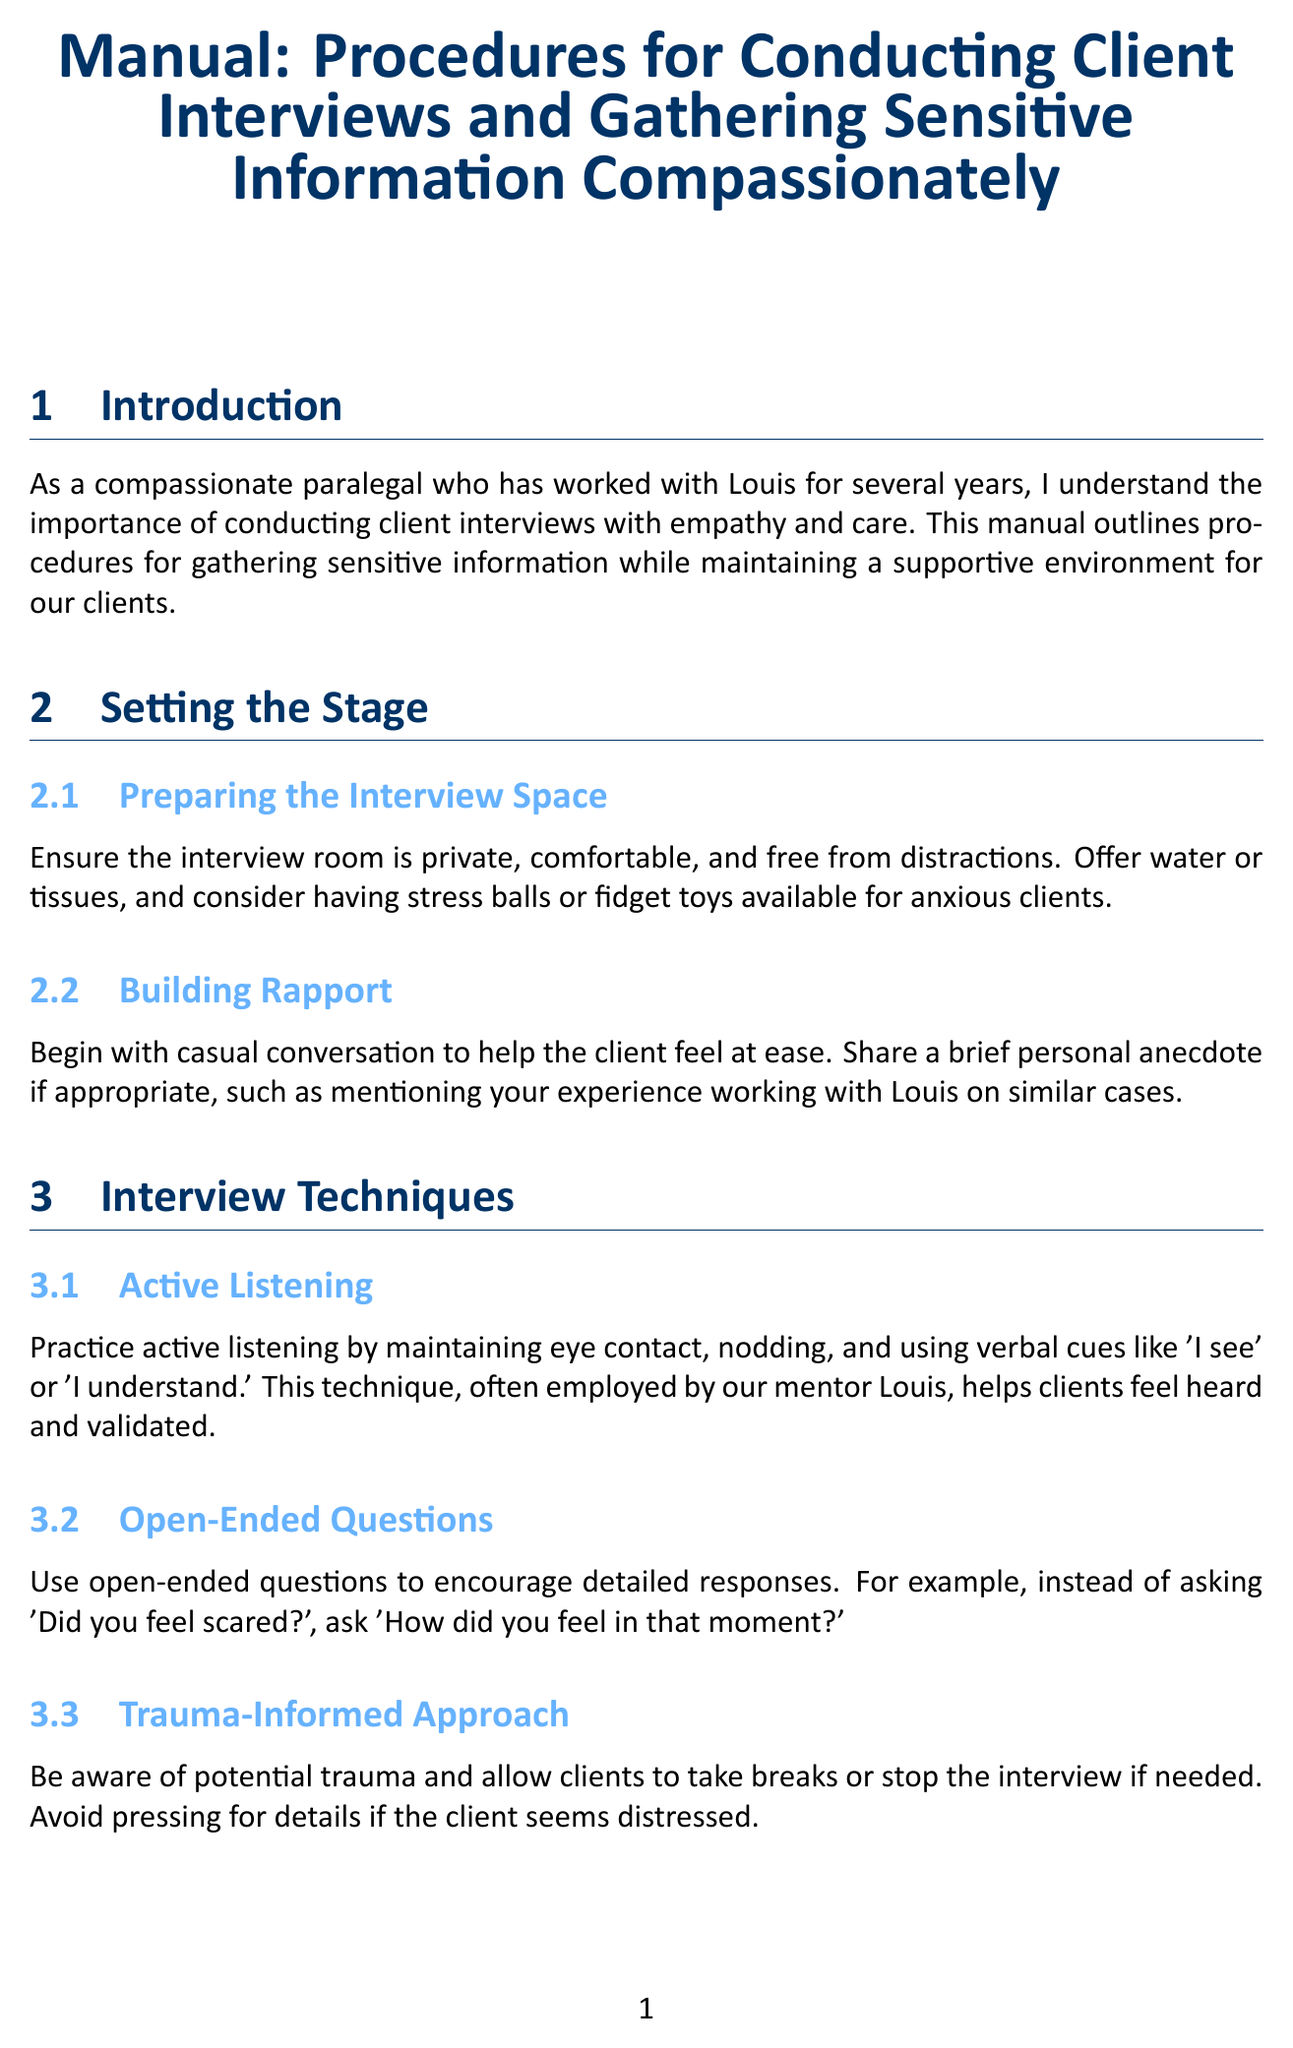What is the title of the manual? The title is stated in the introduction section of the document.
Answer: Manual: Procedures for Conducting Client Interviews and Gathering Sensitive Information Compassionately What is one technique mentioned for building rapport? The section on building rapport provides techniques to ease client tension.
Answer: Casual conversation How should emotional responses be handled during the interview? The document suggests specific phrases to support the client during emotional moments.
Answer: It's okay to take your time What should be explained regarding confidentiality? The section on explaining confidentiality discusses the legal aspect of the client relationship.
Answer: Attorney-client privilege What is one item suggested to prepare the interview space? The section on preparing the interview space lists items that contribute to a supportive environment.
Answer: Tissues What is the importance of cultural sensitivity mentioned in the document? The section on cultural sensitivity highlights the need for awareness in communication styles.
Answer: Mindful of cultural differences What is a key technique recommended for actively listening? The section on active listening emphasizes a specific behavior to show attentiveness.
Answer: Maintaining eye contact What should be done if a client speaks a different language? The document states how to address language differences in client communication.
Answer: Arrange for a certified interpreter What support should be provided at the end of the interview? The concluding section outlines expected outcomes after the interview.
Answer: Information on relevant support services 